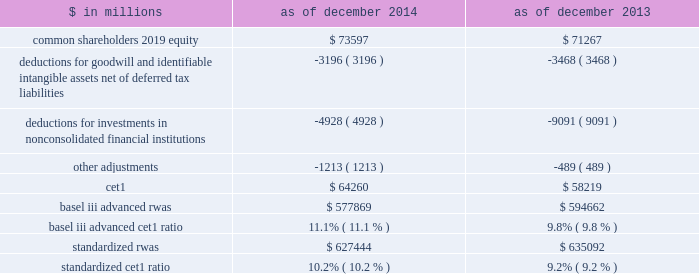Management 2019s discussion and analysis fully phased-in capital ratios the table below presents our estimated ratio of cet1 to rwas calculated under the basel iii advanced rules and the standardized capital rules on a fully phased-in basis. .
Although the fully phased-in capital ratios are not applicable until 2019 , we believe that the estimated ratios in the table above are meaningful because they are measures that we , our regulators and investors use to assess our ability to meet future regulatory capital requirements .
The estimated fully phased-in basel iii advanced and standardized cet1 ratios are non-gaap measures as of both december 2014 and december 2013 and may not be comparable to similar non-gaap measures used by other companies ( as of those dates ) .
These estimated ratios are based on our current interpretation , expectations and understanding of the revised capital framework and may evolve as we discuss its interpretation and application with our regulators .
See note 20 to the consolidated financial statements for information about our transitional capital ratios , which represent our binding ratios as of december 2014 .
In the table above : 2030 the deduction for goodwill and identifiable intangible assets , net of deferred tax liabilities , represents goodwill of $ 3.65 billion and $ 3.71 billion as of december 2014 and december 2013 , respectively , and identifiable intangible assets of $ 515 million and $ 671 million as of december 2014 and december 2013 , respectively , net of associated deferred tax liabilities of $ 964 million and $ 908 million as of december 2014 and december 2013 , respectively .
2030 the deduction for investments in nonconsolidated financial institutions represents the amount by which our investments in the capital of nonconsolidated financial institutions exceed certain prescribed thresholds .
The decrease from december 2013 to december 2014 primarily reflects reductions in our fund investments .
2030 other adjustments primarily include the overfunded portion of our defined benefit pension plan obligation , net of associated deferred tax liabilities , and disallowed deferred tax assets , credit valuation adjustments on derivative liabilities and debt valuation adjustments , as well as other required credit risk-based deductions .
Supplementary leverage ratio the revised capital framework introduces a new supplementary leverage ratio for advanced approach banking organizations .
Under amendments to the revised capital framework , the u.s .
Federal bank regulatory agencies approved a final rule that implements the supplementary leverage ratio aligned with the definition of leverage established by the basel committee .
The supplementary leverage ratio compares tier 1 capital to a measure of leverage exposure , defined as the sum of our quarterly average assets less certain deductions plus certain off-balance-sheet exposures , including a measure of derivatives exposures and commitments .
The revised capital framework requires a minimum supplementary leverage ratio of 5.0% ( 5.0 % ) ( comprised of the minimum requirement of 3.0% ( 3.0 % ) and a 2.0% ( 2.0 % ) buffer ) for u.s .
Banks deemed to be g-sibs , effective on january 1 , 2018 .
Certain disclosures regarding the supplementary leverage ratio are required beginning in the first quarter of 2015 .
As of december 2014 , our estimated supplementary leverage ratio was 5.0% ( 5.0 % ) , including tier 1 capital on a fully phased-in basis of $ 73.17 billion ( cet1 of $ 64.26 billion plus perpetual non-cumulative preferred stock of $ 9.20 billion less other adjustments of $ 290 million ) divided by total leverage exposure of $ 1.45 trillion ( total quarterly average assets of $ 873 billion plus adjustments of $ 579 billion , primarily comprised of off-balance-sheet exposure related to derivatives and commitments ) .
We believe that the estimated supplementary leverage ratio is meaningful because it is a measure that we , our regulators and investors use to assess our ability to meet future regulatory capital requirements .
The supplementary leverage ratio is a non-gaap measure and may not be comparable to similar non-gaap measures used by other companies .
This estimated supplementary leverage ratio is based on our current interpretation and understanding of the u.s .
Federal bank regulatory agencies 2019 final rule and may evolve as we discuss its interpretation and application with our regulators .
60 goldman sachs 2014 annual report .
What is the percentage change in the balance of common shareholders 2019 equity in 2014? 
Computations: ((73597 - 71267) / 71267)
Answer: 0.03269. 